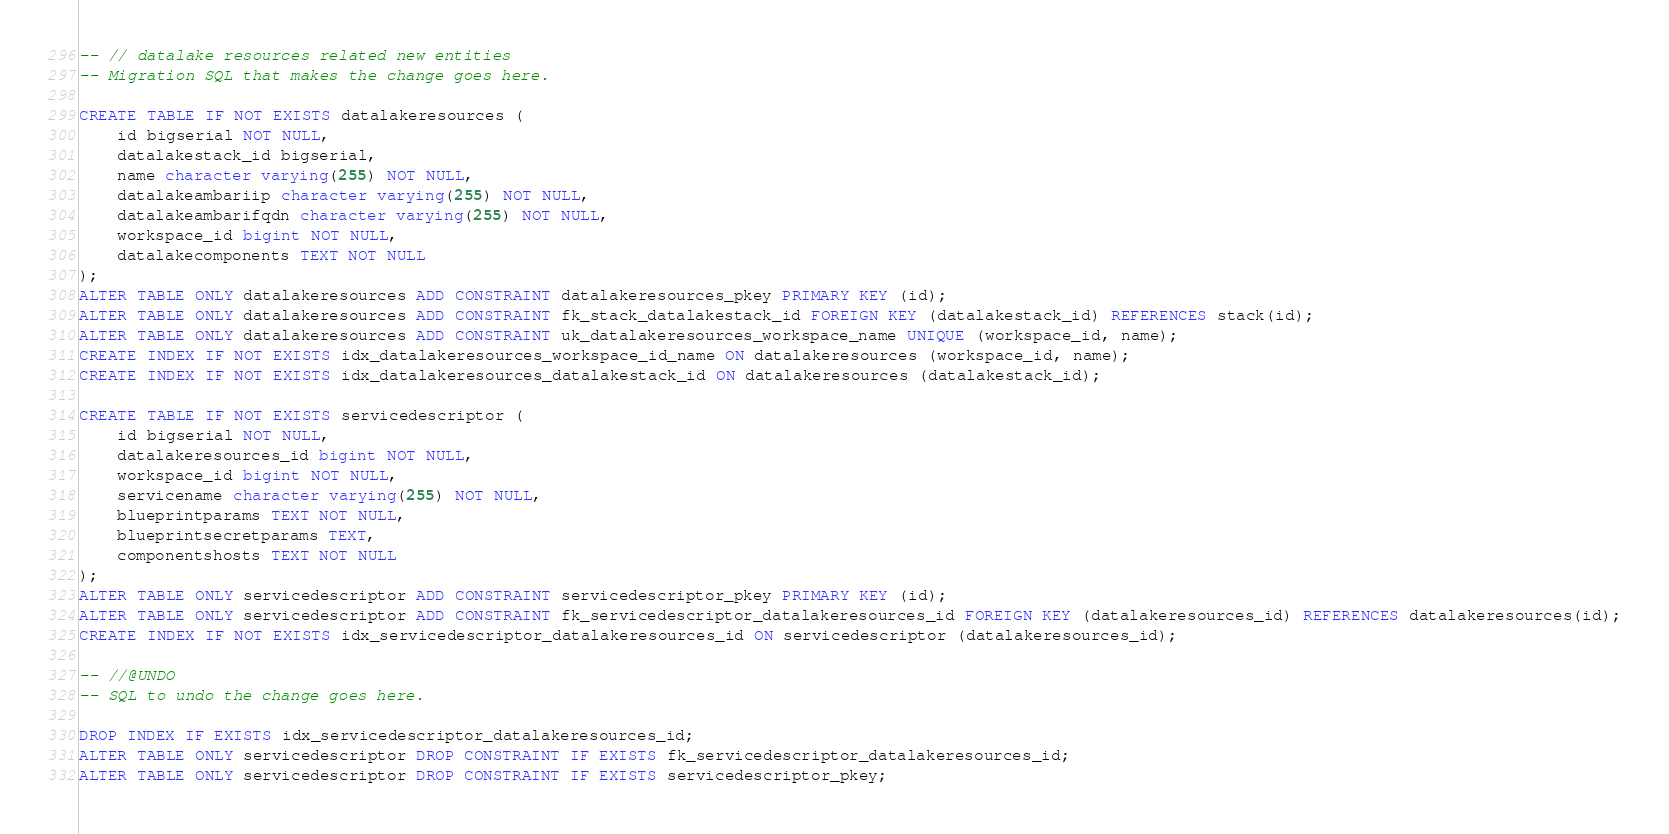Convert code to text. <code><loc_0><loc_0><loc_500><loc_500><_SQL_>-- // datalake resources related new entities
-- Migration SQL that makes the change goes here.

CREATE TABLE IF NOT EXISTS datalakeresources (
    id bigserial NOT NULL,
    datalakestack_id bigserial,
    name character varying(255) NOT NULL,
    datalakeambariip character varying(255) NOT NULL,
    datalakeambarifqdn character varying(255) NOT NULL,
    workspace_id bigint NOT NULL,
    datalakecomponents TEXT NOT NULL
);
ALTER TABLE ONLY datalakeresources ADD CONSTRAINT datalakeresources_pkey PRIMARY KEY (id);
ALTER TABLE ONLY datalakeresources ADD CONSTRAINT fk_stack_datalakestack_id FOREIGN KEY (datalakestack_id) REFERENCES stack(id);
ALTER TABLE ONLY datalakeresources ADD CONSTRAINT uk_datalakeresources_workspace_name UNIQUE (workspace_id, name);
CREATE INDEX IF NOT EXISTS idx_datalakeresources_workspace_id_name ON datalakeresources (workspace_id, name);
CREATE INDEX IF NOT EXISTS idx_datalakeresources_datalakestack_id ON datalakeresources (datalakestack_id);

CREATE TABLE IF NOT EXISTS servicedescriptor (
    id bigserial NOT NULL,
    datalakeresources_id bigint NOT NULL,
    workspace_id bigint NOT NULL,
    servicename character varying(255) NOT NULL,
    blueprintparams TEXT NOT NULL,
    blueprintsecretparams TEXT,
    componentshosts TEXT NOT NULL
);
ALTER TABLE ONLY servicedescriptor ADD CONSTRAINT servicedescriptor_pkey PRIMARY KEY (id);
ALTER TABLE ONLY servicedescriptor ADD CONSTRAINT fk_servicedescriptor_datalakeresources_id FOREIGN KEY (datalakeresources_id) REFERENCES datalakeresources(id);
CREATE INDEX IF NOT EXISTS idx_servicedescriptor_datalakeresources_id ON servicedescriptor (datalakeresources_id);

-- //@UNDO
-- SQL to undo the change goes here.

DROP INDEX IF EXISTS idx_servicedescriptor_datalakeresources_id;
ALTER TABLE ONLY servicedescriptor DROP CONSTRAINT IF EXISTS fk_servicedescriptor_datalakeresources_id;
ALTER TABLE ONLY servicedescriptor DROP CONSTRAINT IF EXISTS servicedescriptor_pkey;</code> 